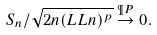<formula> <loc_0><loc_0><loc_500><loc_500>S _ { n } / \sqrt { 2 n ( L L n ) ^ { p } } \stackrel { \P P } { \to } 0 .</formula> 